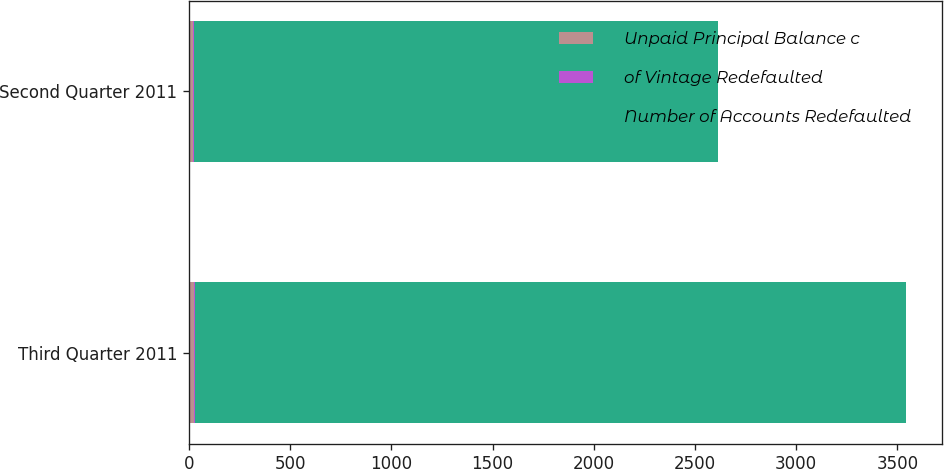Convert chart to OTSL. <chart><loc_0><loc_0><loc_500><loc_500><stacked_bar_chart><ecel><fcel>Third Quarter 2011<fcel>Second Quarter 2011<nl><fcel>Unpaid Principal Balance c<fcel>23<fcel>20<nl><fcel>of Vintage Redefaulted<fcel>4<fcel>5.4<nl><fcel>Number of Accounts Redefaulted<fcel>3514<fcel>2588<nl></chart> 